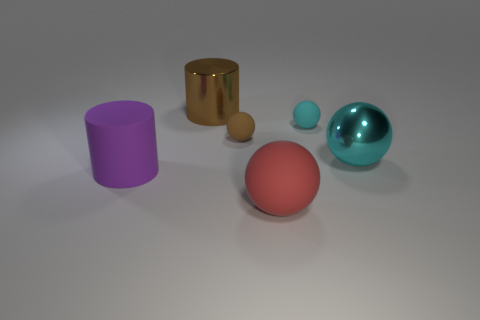There is another cyan thing that is the same shape as the tiny cyan thing; what is it made of?
Provide a short and direct response. Metal. There is a big matte object in front of the purple object; is it the same shape as the small brown thing?
Provide a succinct answer. Yes. What number of objects are behind the large cyan shiny sphere and to the right of the brown shiny thing?
Provide a short and direct response. 2. What number of cyan objects have the same shape as the brown matte object?
Ensure brevity in your answer.  2. What is the color of the cylinder that is in front of the sphere that is right of the cyan rubber object?
Your answer should be compact. Purple. Do the large red object and the brown thing that is in front of the big brown metal cylinder have the same shape?
Your response must be concise. Yes. There is a large sphere that is on the right side of the sphere in front of the large cylinder left of the brown shiny cylinder; what is its material?
Offer a terse response. Metal. Is there a cyan object that has the same size as the metallic cylinder?
Make the answer very short. Yes. What size is the cylinder that is the same material as the small cyan object?
Offer a very short reply. Large. What is the shape of the brown rubber thing?
Provide a succinct answer. Sphere. 